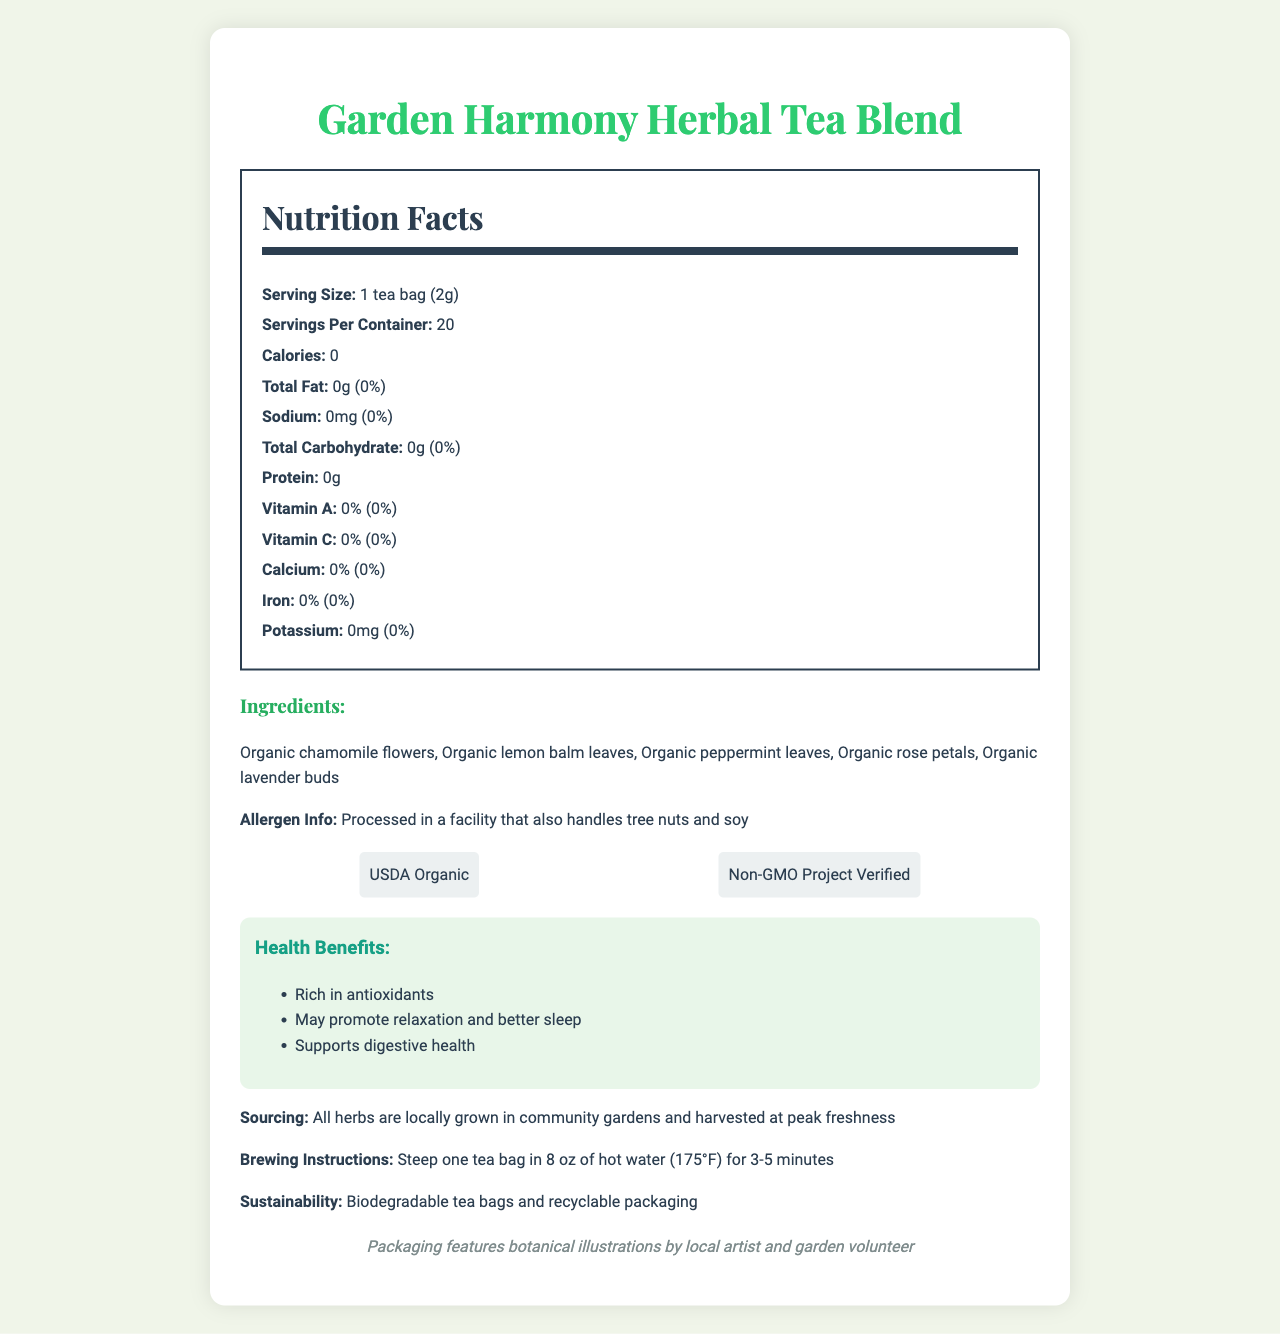what is the serving size? The serving size is listed at the top of the nutrition facts, indicating it is 1 tea bag which weighs 2 grams.
Answer: 1 tea bag (2g) how many servings are in each container? The number of servings per container is specified directly in the nutrition facts section of the document.
Answer: 20 does the tea contain any fat? The nutrition facts indicate that there is 0g of total fat in the tea.
Answer: No what is the percentage of daily value for calcium provided by this tea? The nutrition facts section lists the daily value for calcium as 0%.
Answer: 0% where are the herbs sourced from? The sourcing information at the bottom of the document states that all herbs are locally grown in community gardens and harvested at peak freshness.
Answer: Locally grown in community gardens what is the recommended brewing temperature for this tea? The brewing instructions mention that you should steep the tea in 8 oz of hot water at 175°F.
Answer: 175°F which of the following certifications does the tea have? A. Certified Gluten-Free B. USDA Organic C. Fair Trade Certified D. Non-GMO Project Verified The certification section includes USDA Organic and Non-GMO Project Verified.
Answer: B and D which of the following ingredients is not included in the tea blend? A. Organic chamomile flowers B. Organic lemon balm leaves C. Organic dandelion roots D. Organic lavender buds The ingredient list does not mention organic dandelion roots, while all other options are listed.
Answer: C is the tea processed in a facility that handles soy? The allergen information specifies that the tea is processed in a facility that also handles tree nuts and soy.
Answer: Yes summarize the main idea of the document. The document is focused on delivering comprehensive data regarding the composition, benefits, and background of the Garden Harmony Herbal Tea Blend. It aims to inform consumers about what makes this product unique and aligned with sustainable, healthy, and locally supportive practices.
Answer: The document provides detailed information about the Garden Harmony Herbal Tea Blend, including its nutrition facts, ingredients, health benefits, allergen info, certifications, and sourcing. It emphasizes that the tea contains zero calories, fats, and proteins, and is rich in antioxidants. The herbs are locally grown in community gardens, and the product comes with sustainable packaging. Brewing instructions and artist notes highlight the community and artistic efforts behind the product. how much potassium does the tea contain? The nutrition facts section states that the tea contains no potassium, quantified at 0mg.
Answer: 0mg why is the garden harmony herbal tea blend beneficial for health? A. It is rich in protein B. Contains antioxidants C. High in sugar D. Provides Vitamin C The health benefits section highlights that the tea is rich in antioxidants, which is beneficial for health.
Answer: B what is the source of the botanical illustrations on the packaging? The artist note mentions that the packaging features botanical illustrations by a local artist and garden volunteer.
Answer: Local artist and garden volunteer how much protein is in a serving? The nutrition facts list the protein content per serving as 0 grams.
Answer: 0g can the vitamin C content of the tea be determined from the document? The vitamin C content is directly listed as 0% in the nutrition facts section.
Answer: Yes do the claims that the tea may promote relaxation and better sleep have specific scientific citations in the document? The health benefits section mentions potential health benefits like promoting relaxation and better sleep but does not provide specific scientific citations to support these claims.
Answer: No does the tea provide any fiber? The nutrition facts do not mention fiber content, so we cannot determine if the tea provides any dietary fiber.
Answer: Not enough information is the packaging of the tea recyclable? The sustainability section states that the tea bags are biodegradable and the packaging is recyclable.
Answer: Yes 